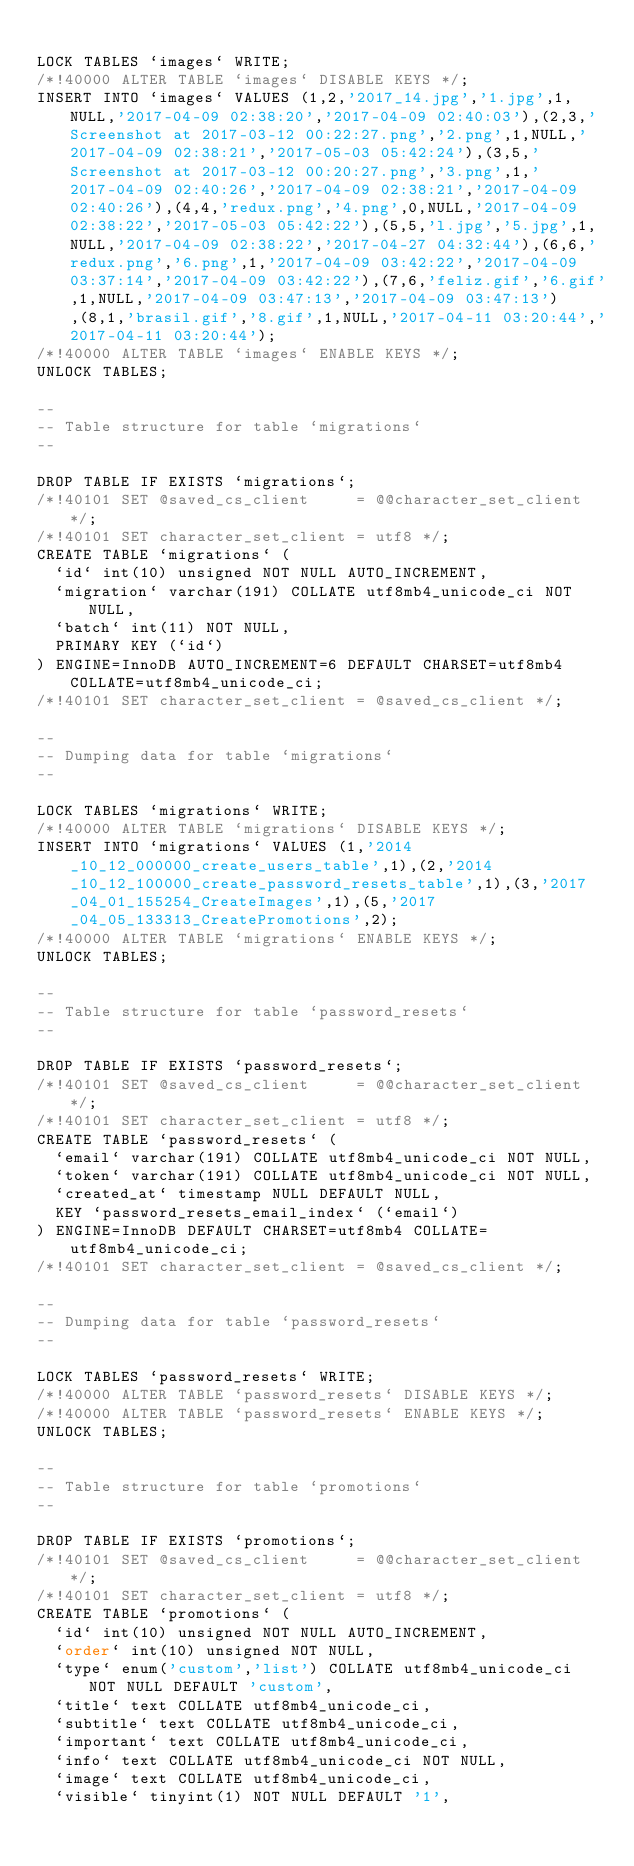<code> <loc_0><loc_0><loc_500><loc_500><_SQL_>
LOCK TABLES `images` WRITE;
/*!40000 ALTER TABLE `images` DISABLE KEYS */;
INSERT INTO `images` VALUES (1,2,'2017_14.jpg','1.jpg',1,NULL,'2017-04-09 02:38:20','2017-04-09 02:40:03'),(2,3,'Screenshot at 2017-03-12 00:22:27.png','2.png',1,NULL,'2017-04-09 02:38:21','2017-05-03 05:42:24'),(3,5,'Screenshot at 2017-03-12 00:20:27.png','3.png',1,'2017-04-09 02:40:26','2017-04-09 02:38:21','2017-04-09 02:40:26'),(4,4,'redux.png','4.png',0,NULL,'2017-04-09 02:38:22','2017-05-03 05:42:22'),(5,5,'l.jpg','5.jpg',1,NULL,'2017-04-09 02:38:22','2017-04-27 04:32:44'),(6,6,'redux.png','6.png',1,'2017-04-09 03:42:22','2017-04-09 03:37:14','2017-04-09 03:42:22'),(7,6,'feliz.gif','6.gif',1,NULL,'2017-04-09 03:47:13','2017-04-09 03:47:13'),(8,1,'brasil.gif','8.gif',1,NULL,'2017-04-11 03:20:44','2017-04-11 03:20:44');
/*!40000 ALTER TABLE `images` ENABLE KEYS */;
UNLOCK TABLES;

--
-- Table structure for table `migrations`
--

DROP TABLE IF EXISTS `migrations`;
/*!40101 SET @saved_cs_client     = @@character_set_client */;
/*!40101 SET character_set_client = utf8 */;
CREATE TABLE `migrations` (
  `id` int(10) unsigned NOT NULL AUTO_INCREMENT,
  `migration` varchar(191) COLLATE utf8mb4_unicode_ci NOT NULL,
  `batch` int(11) NOT NULL,
  PRIMARY KEY (`id`)
) ENGINE=InnoDB AUTO_INCREMENT=6 DEFAULT CHARSET=utf8mb4 COLLATE=utf8mb4_unicode_ci;
/*!40101 SET character_set_client = @saved_cs_client */;

--
-- Dumping data for table `migrations`
--

LOCK TABLES `migrations` WRITE;
/*!40000 ALTER TABLE `migrations` DISABLE KEYS */;
INSERT INTO `migrations` VALUES (1,'2014_10_12_000000_create_users_table',1),(2,'2014_10_12_100000_create_password_resets_table',1),(3,'2017_04_01_155254_CreateImages',1),(5,'2017_04_05_133313_CreatePromotions',2);
/*!40000 ALTER TABLE `migrations` ENABLE KEYS */;
UNLOCK TABLES;

--
-- Table structure for table `password_resets`
--

DROP TABLE IF EXISTS `password_resets`;
/*!40101 SET @saved_cs_client     = @@character_set_client */;
/*!40101 SET character_set_client = utf8 */;
CREATE TABLE `password_resets` (
  `email` varchar(191) COLLATE utf8mb4_unicode_ci NOT NULL,
  `token` varchar(191) COLLATE utf8mb4_unicode_ci NOT NULL,
  `created_at` timestamp NULL DEFAULT NULL,
  KEY `password_resets_email_index` (`email`)
) ENGINE=InnoDB DEFAULT CHARSET=utf8mb4 COLLATE=utf8mb4_unicode_ci;
/*!40101 SET character_set_client = @saved_cs_client */;

--
-- Dumping data for table `password_resets`
--

LOCK TABLES `password_resets` WRITE;
/*!40000 ALTER TABLE `password_resets` DISABLE KEYS */;
/*!40000 ALTER TABLE `password_resets` ENABLE KEYS */;
UNLOCK TABLES;

--
-- Table structure for table `promotions`
--

DROP TABLE IF EXISTS `promotions`;
/*!40101 SET @saved_cs_client     = @@character_set_client */;
/*!40101 SET character_set_client = utf8 */;
CREATE TABLE `promotions` (
  `id` int(10) unsigned NOT NULL AUTO_INCREMENT,
  `order` int(10) unsigned NOT NULL,
  `type` enum('custom','list') COLLATE utf8mb4_unicode_ci NOT NULL DEFAULT 'custom',
  `title` text COLLATE utf8mb4_unicode_ci,
  `subtitle` text COLLATE utf8mb4_unicode_ci,
  `important` text COLLATE utf8mb4_unicode_ci,
  `info` text COLLATE utf8mb4_unicode_ci NOT NULL,
  `image` text COLLATE utf8mb4_unicode_ci,
  `visible` tinyint(1) NOT NULL DEFAULT '1',</code> 